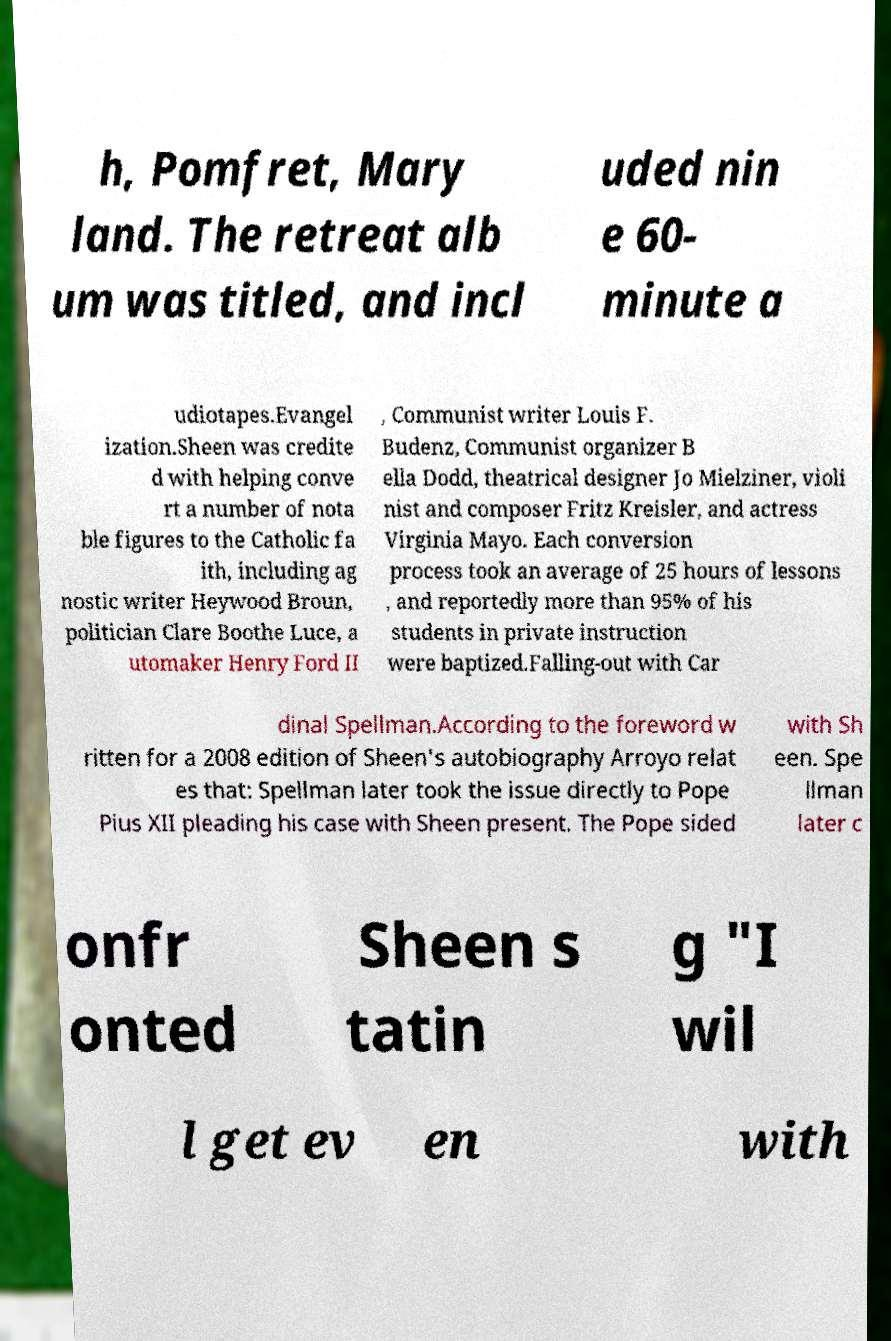For documentation purposes, I need the text within this image transcribed. Could you provide that? h, Pomfret, Mary land. The retreat alb um was titled, and incl uded nin e 60- minute a udiotapes.Evangel ization.Sheen was credite d with helping conve rt a number of nota ble figures to the Catholic fa ith, including ag nostic writer Heywood Broun, politician Clare Boothe Luce, a utomaker Henry Ford II , Communist writer Louis F. Budenz, Communist organizer B ella Dodd, theatrical designer Jo Mielziner, violi nist and composer Fritz Kreisler, and actress Virginia Mayo. Each conversion process took an average of 25 hours of lessons , and reportedly more than 95% of his students in private instruction were baptized.Falling-out with Car dinal Spellman.According to the foreword w ritten for a 2008 edition of Sheen's autobiography Arroyo relat es that: Spellman later took the issue directly to Pope Pius XII pleading his case with Sheen present. The Pope sided with Sh een. Spe llman later c onfr onted Sheen s tatin g "I wil l get ev en with 